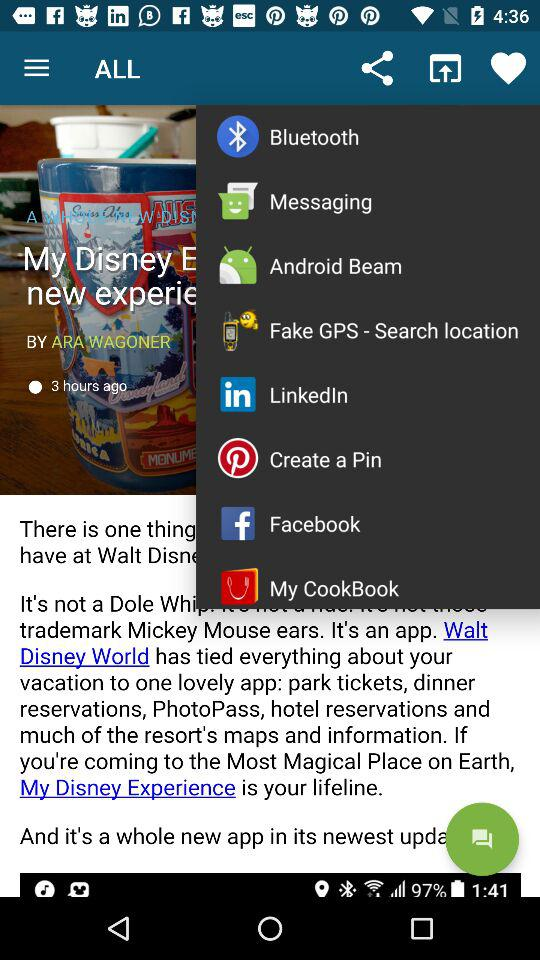Who's the author of the article? The author of the article is Ara Wagoner. 